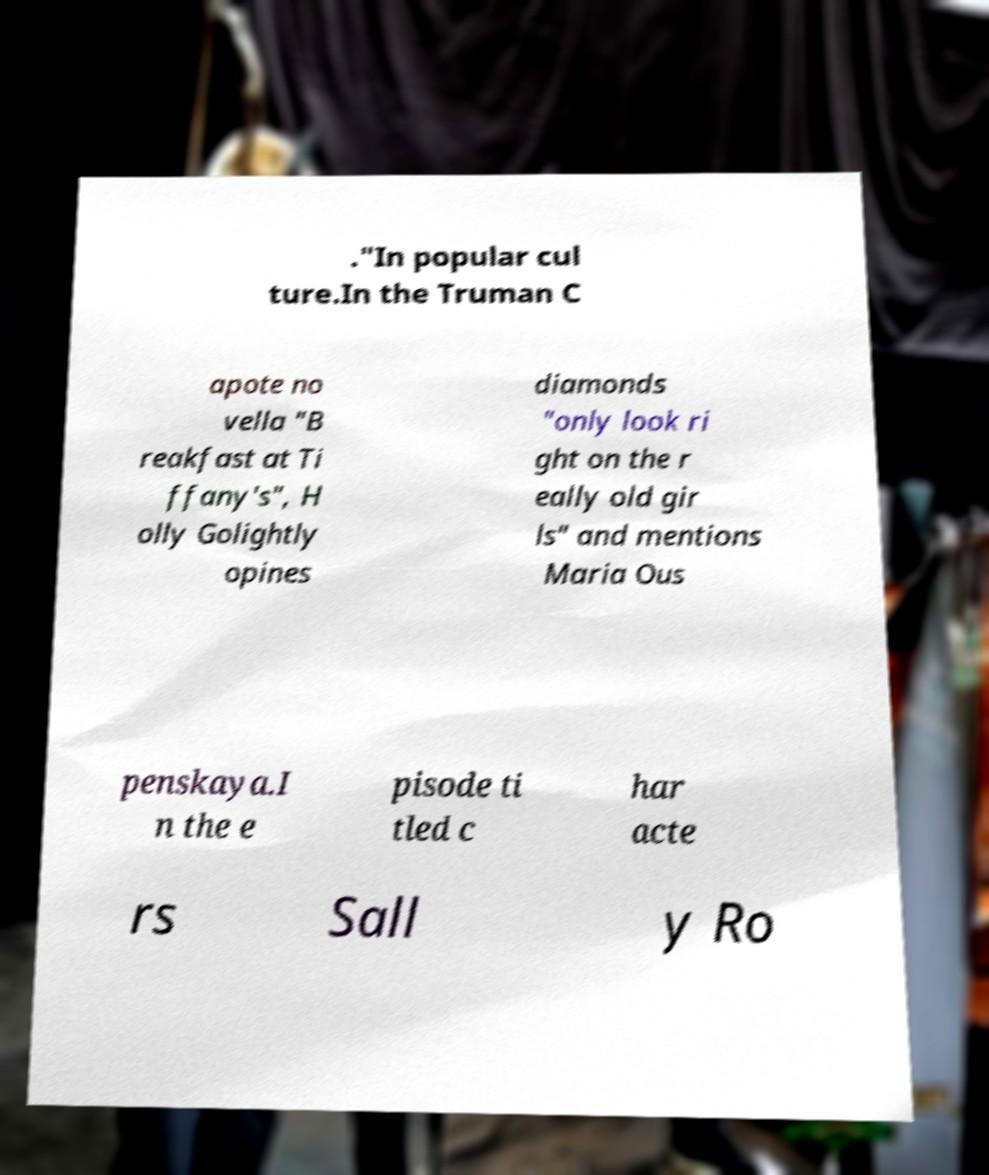Could you extract and type out the text from this image? ."In popular cul ture.In the Truman C apote no vella "B reakfast at Ti ffany's", H olly Golightly opines diamonds "only look ri ght on the r eally old gir ls" and mentions Maria Ous penskaya.I n the e pisode ti tled c har acte rs Sall y Ro 